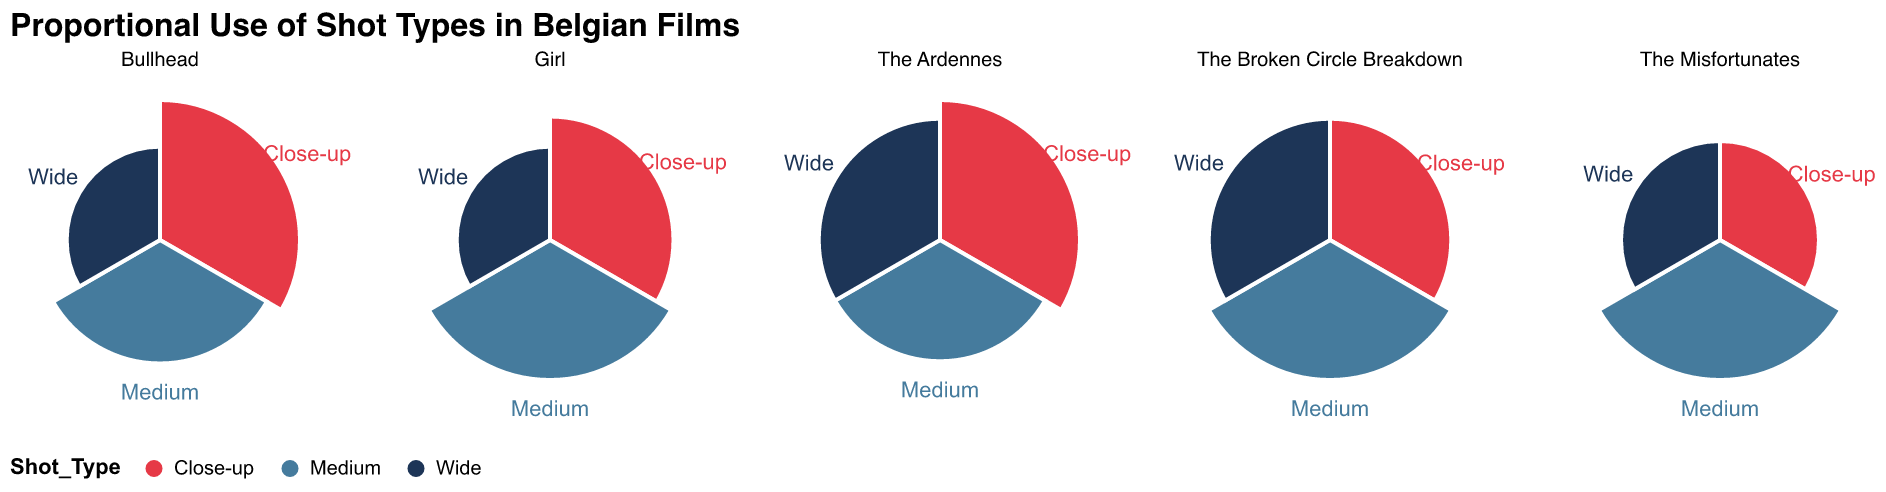What is the title of the figure? The title is located at the top of the chart, displaying the main topic or subject it represents.
Answer: Proportional Use of Shot Types in Belgian Films Which film uses the highest proportion of Close-up shots? By examining the radial extension representing Close-up shots across all subplots, the longest is for "Bullhead" at 0.45.
Answer: Bullhead What is the sum of the proportions of Medium shots for "Girl" and "The Misfortunates"? The proportion for "Girl" is 0.45 and for "The Misfortunates" is 0.50. Summing these values: 0.45 + 0.50 = 0.95.
Answer: 0.95 Which film has the smallest proportion of Wide shots, and what is that proportion? By looking at the radial extension for Wide shots in all subplots, "Girl" and "Bullhead" each have the smallest proportion at 0.20.
Answer: Girl and Bullhead, 0.20 Compare the proportion of Close-up shots in "The Ardennes" and "The Broken Circle Breakdown." Which is larger and by how much? "The Ardennes" has a proportion of 0.40 for Close-up shots, while "The Broken Circle Breakdown" has 0.30. The difference is 0.40 - 0.30 = 0.10.
Answer: "The Ardennes" by 0.10 What is the average proportion of Medium shots among all the films? Sum the proportions of Medium shots: 0.45 + 0.30 + 0.50 + 0.35 + 0.40 = 2.00. Dividing by the number of films, 2.00 / 5 = 0.40.
Answer: 0.40 Which film has the most balanced use of shot types in terms of proportions, and why? "The Ardennes" has proportions of 0.40 (Close-up), 0.30 (Medium), and 0.30 (Wide), which are the most similar compared to the other films.
Answer: The Ardennes How does the use of Wide shots in "The Misfortunates" compare to "The Broken Circle Breakdown"? Both films have an equal proportion of Wide shots at 0.30.
Answer: The same, 0.30 What is the total proportion of all shot types in "Bullhead"? Summing the proportions: 0.45 (Close-up) + 0.35 (Medium) + 0.20 (Wide) = 1.00.
Answer: 1.00 